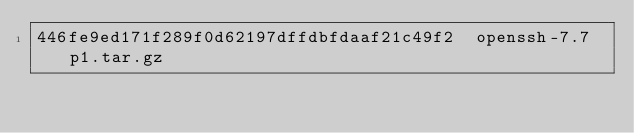<code> <loc_0><loc_0><loc_500><loc_500><_SML_>446fe9ed171f289f0d62197dffdbfdaaf21c49f2  openssh-7.7p1.tar.gz
</code> 